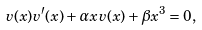Convert formula to latex. <formula><loc_0><loc_0><loc_500><loc_500>v ( x ) v ^ { \prime } ( x ) + \alpha x v ( x ) + \beta x ^ { 3 } = 0 ,</formula> 